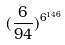Convert formula to latex. <formula><loc_0><loc_0><loc_500><loc_500>( \frac { 6 } { 9 4 } ) ^ { 6 ^ { 1 4 6 } }</formula> 